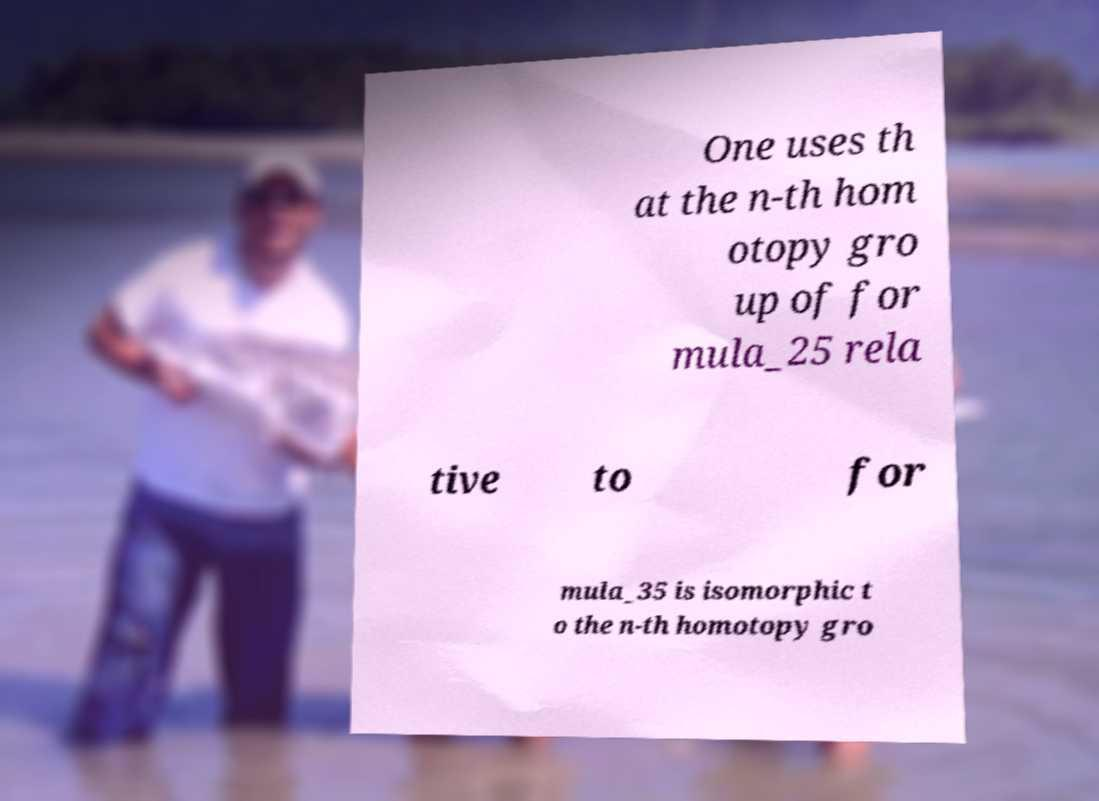Please identify and transcribe the text found in this image. One uses th at the n-th hom otopy gro up of for mula_25 rela tive to for mula_35 is isomorphic t o the n-th homotopy gro 